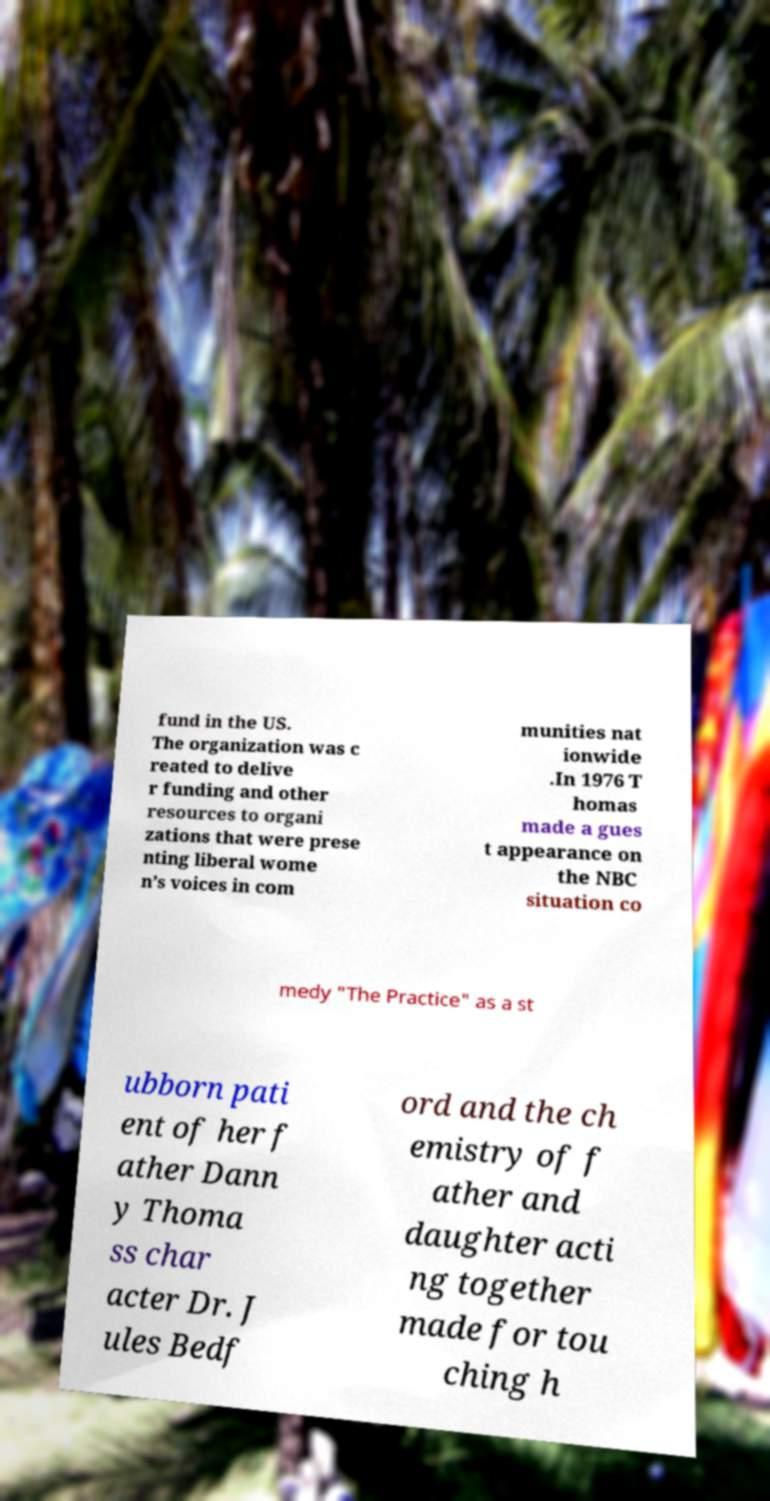Please identify and transcribe the text found in this image. fund in the US. The organization was c reated to delive r funding and other resources to organi zations that were prese nting liberal wome n’s voices in com munities nat ionwide .In 1976 T homas made a gues t appearance on the NBC situation co medy "The Practice" as a st ubborn pati ent of her f ather Dann y Thoma ss char acter Dr. J ules Bedf ord and the ch emistry of f ather and daughter acti ng together made for tou ching h 